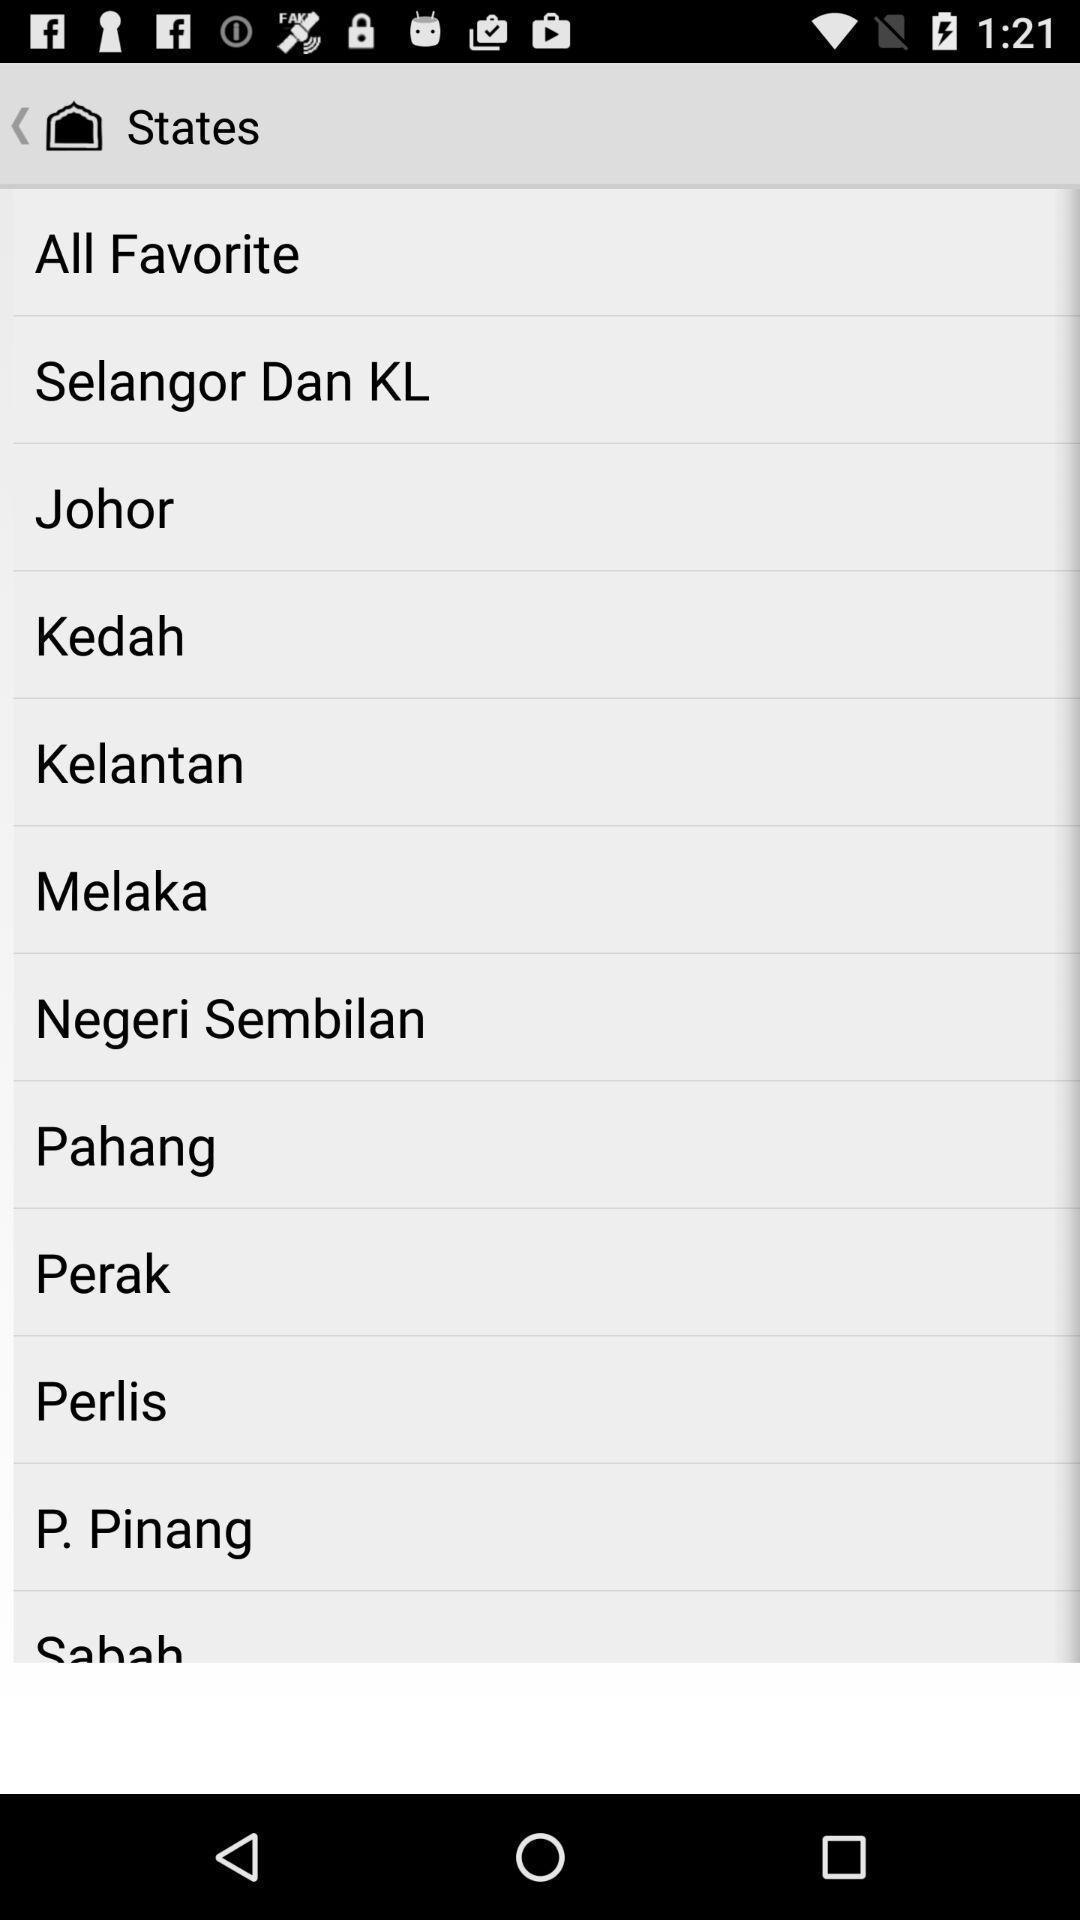Describe the content in this image. Screen showing list of various states. 